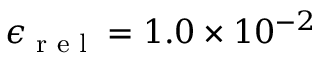Convert formula to latex. <formula><loc_0><loc_0><loc_500><loc_500>\epsilon _ { r e l } = 1 . 0 \times 1 0 ^ { - 2 }</formula> 